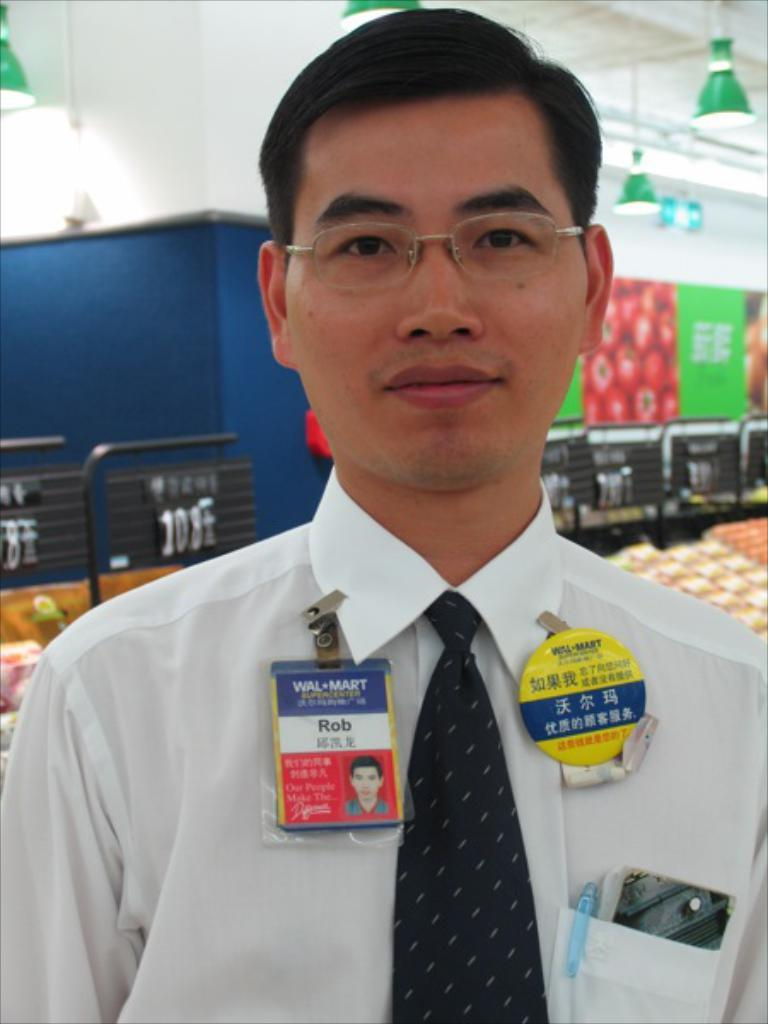What is present in the image? There is a person in the image. Can you describe the person's attire? The person is wearing clothes and badges. What can be seen in the middle of the image? There is a wall in the middle of the image. What type of lighting is present in the image? There are lights hanging from the ceiling in the image. Reasoning: Let' Let's think step by step in order to produce the conversation. We start by identifying the main subject in the image, which is the person. Then, we describe the person's attire, including the clothes and badges they are wearing. Next, we mention the wall in the middle of the image, which is another prominent feature. Finally, we focus on the lighting in the image, specifically the lights hanging from the ceiling. Each question is designed to elicit a specific detail about the image that is known from the provided facts. Absurd Question/Answer: What type of steel structure can be seen in the image? There is no steel structure present in the image. How many holes are visible in the person's clothing in the image? The provided facts do not mention any holes in the person's clothing, so we cannot determine the number of holes from the image. --- Facts: 1. There is a car in the image. 2. The car is parked on the street. 3. The car is red. 4. There are trees in the background of the image. 5. The sky is visible in the image. Absurd Topics: parrot, sand, umbrella Conversation: What is the main subject of the image? The main subject of the image is a car. Where is the car located in the image? The car is parked on the street. Can you describe the color of the car? The car is red. What can be seen in the background of the image? There are trees in the background of the image. What is visible in the sky in the image? The sky is visible in the image. Can you tell me how many parrots are sitting on the car in the image? There are no parrots present in the image. What type of sand can be seen on the car's tires in the image? There is no sand visible in the image, and the car's tires are not mentioned in the provided facts. --- Facts: 1. There is a group of people in the image. 2. The people are wearing hats. 3. The people are holding umbrellas. 4. There is a building in the background of the image. 5. The ground is visible in the image. Absurd Topics: snow, fish, bicycle Conversation: What is the main subject of the image? The main subject of the image is a group of people. Q: 